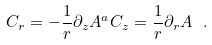<formula> <loc_0><loc_0><loc_500><loc_500>C _ { r } = - \frac { 1 } { r } \partial _ { z } A ^ { a } C _ { z } = \frac { 1 } { r } \partial _ { r } A \ .</formula> 